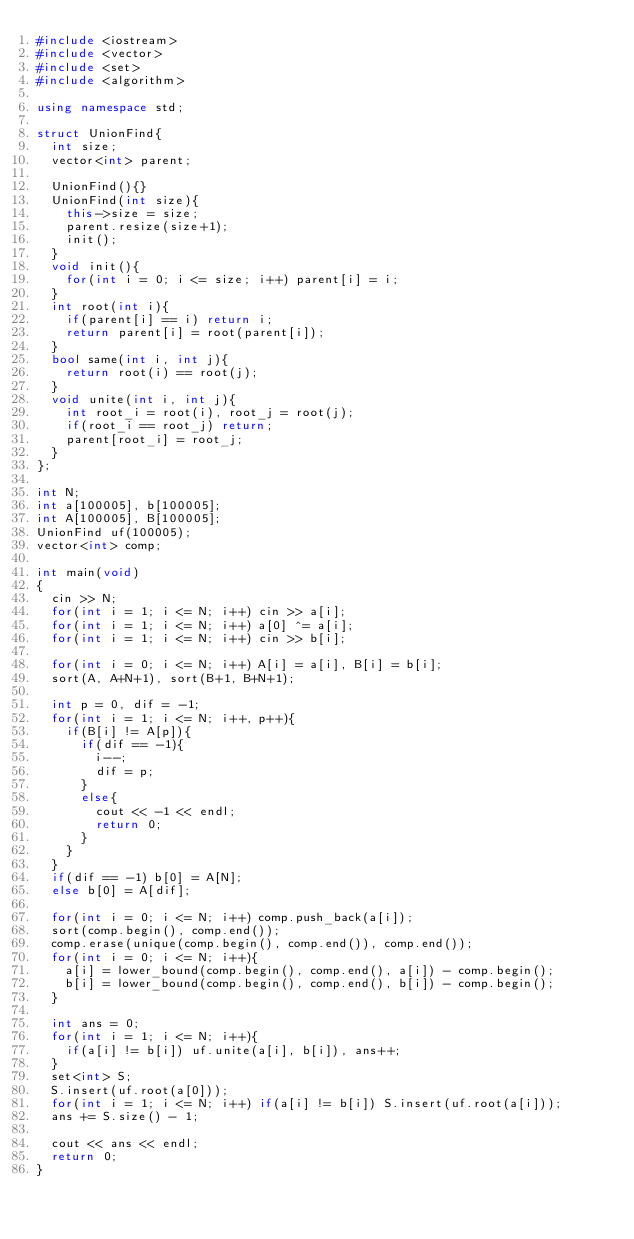Convert code to text. <code><loc_0><loc_0><loc_500><loc_500><_C++_>#include <iostream>
#include <vector>
#include <set>
#include <algorithm>

using namespace std;

struct UnionFind{
	int size;
	vector<int> parent;
	
	UnionFind(){}
	UnionFind(int size){
		this->size = size;
		parent.resize(size+1);
		init();
	}
	void init(){
		for(int i = 0; i <= size; i++) parent[i] = i;
	}
	int root(int i){
		if(parent[i] == i) return i;
		return parent[i] = root(parent[i]);
	}
	bool same(int i, int j){
		return root(i) == root(j);
	}
	void unite(int i, int j){
		int root_i = root(i), root_j = root(j);
		if(root_i == root_j) return;
		parent[root_i] = root_j;
	}
};

int N;
int a[100005], b[100005];
int A[100005], B[100005];
UnionFind uf(100005);
vector<int> comp;

int main(void)
{
	cin >> N;
	for(int i = 1; i <= N; i++) cin >> a[i];
	for(int i = 1; i <= N; i++) a[0] ^= a[i];
	for(int i = 1; i <= N; i++) cin >> b[i];
	
	for(int i = 0; i <= N; i++) A[i] = a[i], B[i] = b[i];
	sort(A, A+N+1), sort(B+1, B+N+1);
	
	int p = 0, dif = -1;
	for(int i = 1; i <= N; i++, p++){
		if(B[i] != A[p]){
			if(dif == -1){
				i--;
				dif = p;
			}
			else{
				cout << -1 << endl;
				return 0;
			}
		}
	}
	if(dif == -1) b[0] = A[N];
	else b[0] = A[dif];
	
	for(int i = 0; i <= N; i++) comp.push_back(a[i]);
	sort(comp.begin(), comp.end());
	comp.erase(unique(comp.begin(), comp.end()), comp.end());
	for(int i = 0; i <= N; i++){
		a[i] = lower_bound(comp.begin(), comp.end(), a[i]) - comp.begin();
		b[i] = lower_bound(comp.begin(), comp.end(), b[i]) - comp.begin();
	}
	
	int ans = 0;
	for(int i = 1; i <= N; i++){
		if(a[i] != b[i]) uf.unite(a[i], b[i]), ans++;
	}
	set<int> S;
	S.insert(uf.root(a[0]));
	for(int i = 1; i <= N; i++) if(a[i] != b[i]) S.insert(uf.root(a[i]));
	ans += S.size() - 1;
	
	cout << ans << endl;
	return 0;
}</code> 